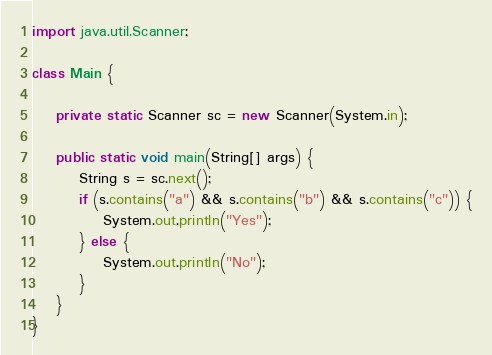Convert code to text. <code><loc_0><loc_0><loc_500><loc_500><_Java_>import java.util.Scanner;

class Main {

    private static Scanner sc = new Scanner(System.in);

    public static void main(String[] args) {
        String s = sc.next();
        if (s.contains("a") && s.contains("b") && s.contains("c")) {
            System.out.println("Yes");
        } else {
            System.out.println("No");
        }
    }
}</code> 